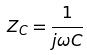Convert formula to latex. <formula><loc_0><loc_0><loc_500><loc_500>Z _ { C } = \frac { 1 } { j \omega C }</formula> 